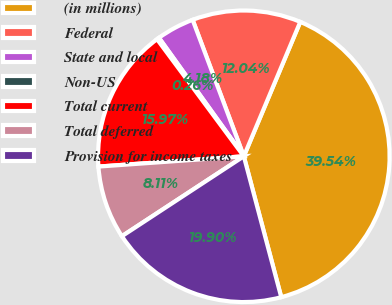Convert chart. <chart><loc_0><loc_0><loc_500><loc_500><pie_chart><fcel>(in millions)<fcel>Federal<fcel>State and local<fcel>Non-US<fcel>Total current<fcel>Total deferred<fcel>Provision for income taxes<nl><fcel>39.54%<fcel>12.04%<fcel>4.18%<fcel>0.26%<fcel>15.97%<fcel>8.11%<fcel>19.9%<nl></chart> 